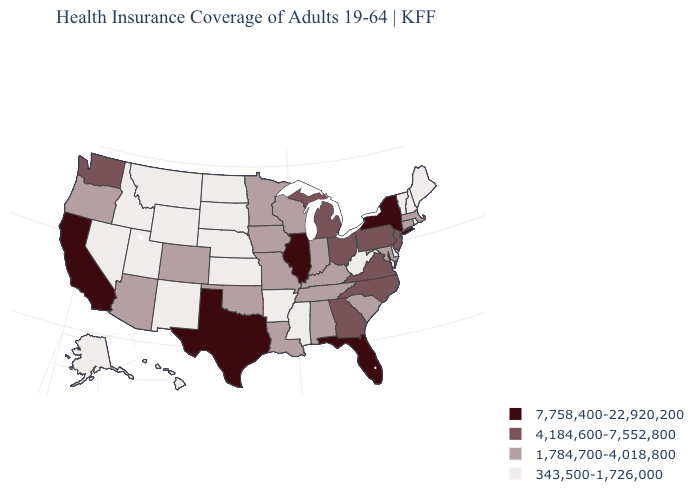Name the states that have a value in the range 343,500-1,726,000?
Quick response, please. Alaska, Arkansas, Delaware, Hawaii, Idaho, Kansas, Maine, Mississippi, Montana, Nebraska, Nevada, New Hampshire, New Mexico, North Dakota, Rhode Island, South Dakota, Utah, Vermont, West Virginia, Wyoming. Name the states that have a value in the range 4,184,600-7,552,800?
Write a very short answer. Georgia, Michigan, New Jersey, North Carolina, Ohio, Pennsylvania, Virginia, Washington. What is the highest value in states that border Montana?
Give a very brief answer. 343,500-1,726,000. Name the states that have a value in the range 7,758,400-22,920,200?
Keep it brief. California, Florida, Illinois, New York, Texas. What is the value of Missouri?
Write a very short answer. 1,784,700-4,018,800. Name the states that have a value in the range 7,758,400-22,920,200?
Be succinct. California, Florida, Illinois, New York, Texas. What is the lowest value in states that border Mississippi?
Answer briefly. 343,500-1,726,000. Which states hav the highest value in the West?
Concise answer only. California. What is the highest value in the USA?
Write a very short answer. 7,758,400-22,920,200. What is the value of Tennessee?
Short answer required. 1,784,700-4,018,800. Does Michigan have a lower value than New York?
Write a very short answer. Yes. What is the highest value in states that border Colorado?
Short answer required. 1,784,700-4,018,800. Does the map have missing data?
Short answer required. No. Does the first symbol in the legend represent the smallest category?
Be succinct. No. 